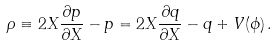Convert formula to latex. <formula><loc_0><loc_0><loc_500><loc_500>\rho \equiv 2 X \frac { \partial p } { \partial X } - p = 2 X \frac { \partial q } { \partial X } - q + V ( \phi ) \, .</formula> 